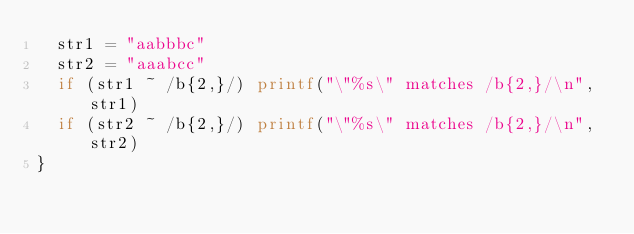Convert code to text. <code><loc_0><loc_0><loc_500><loc_500><_Awk_>	str1 = "aabbbc"
	str2 = "aaabcc"
	if (str1 ~ /b{2,}/) printf("\"%s\" matches /b{2,}/\n", str1)
	if (str2 ~ /b{2,}/) printf("\"%s\" matches /b{2,}/\n", str2)
}
</code> 